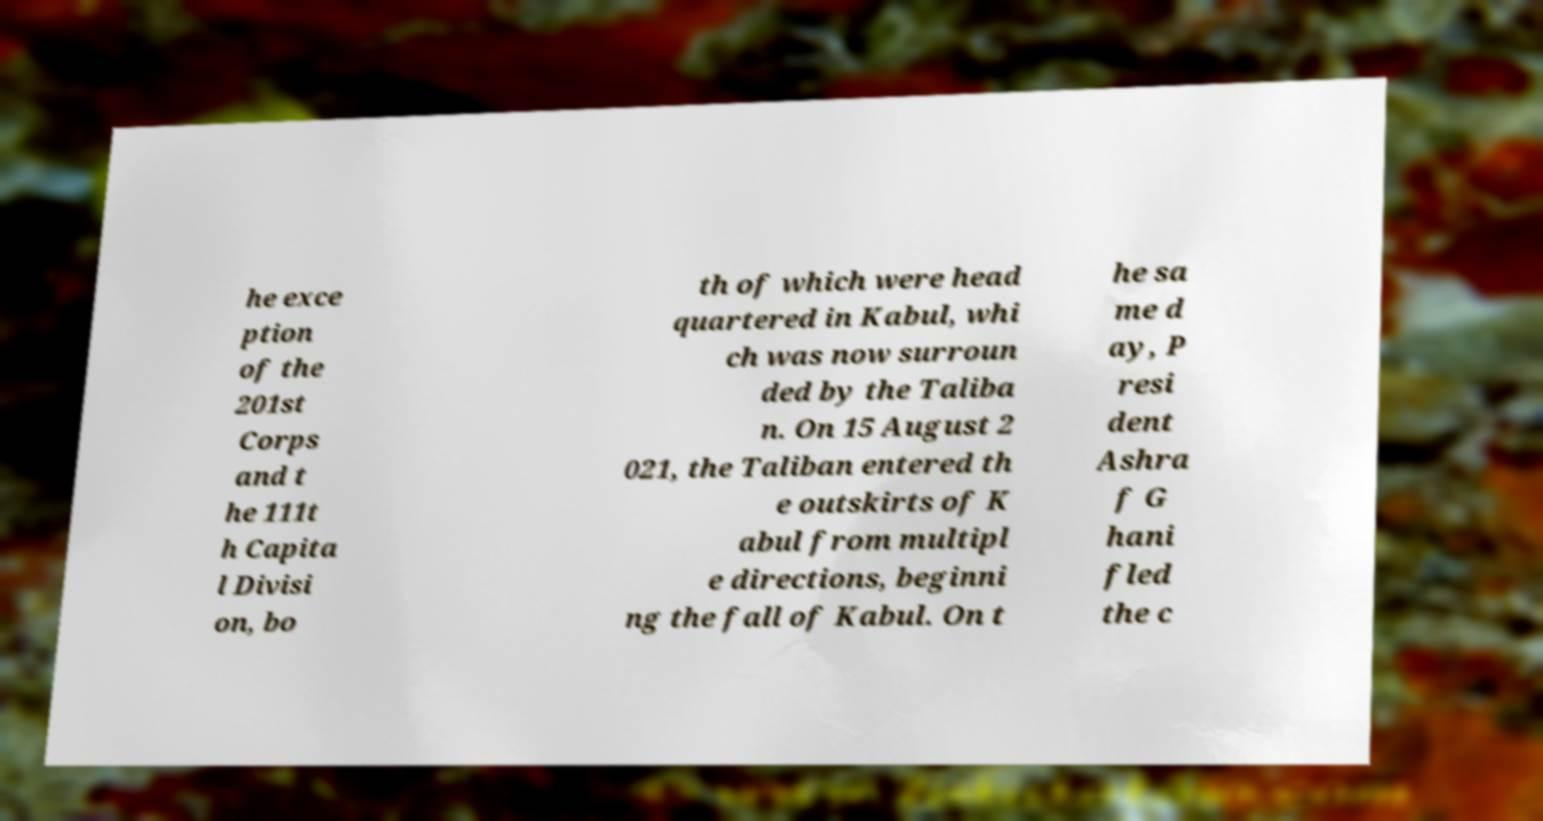Could you extract and type out the text from this image? he exce ption of the 201st Corps and t he 111t h Capita l Divisi on, bo th of which were head quartered in Kabul, whi ch was now surroun ded by the Taliba n. On 15 August 2 021, the Taliban entered th e outskirts of K abul from multipl e directions, beginni ng the fall of Kabul. On t he sa me d ay, P resi dent Ashra f G hani fled the c 